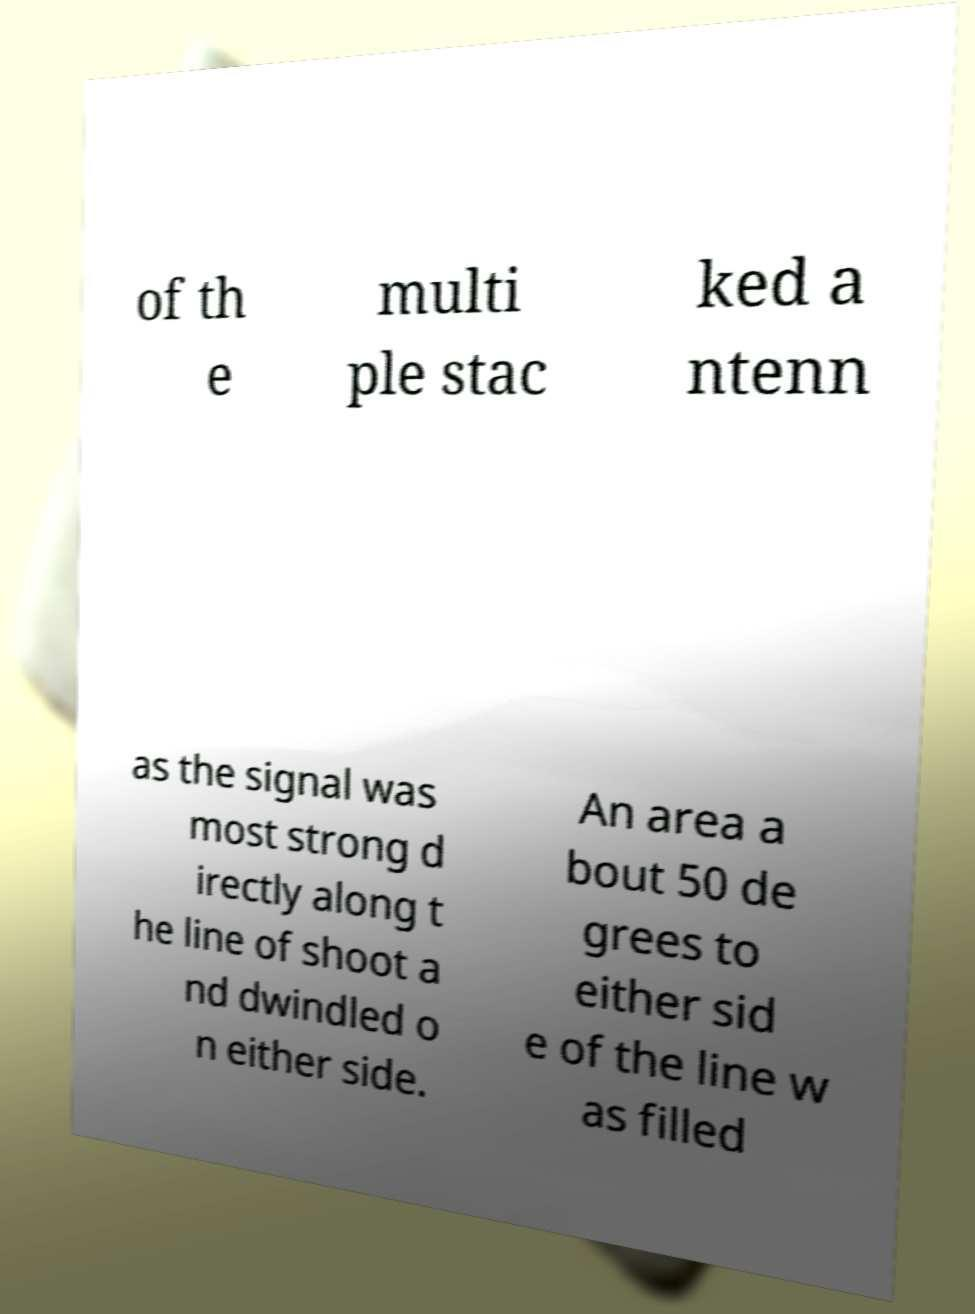Please read and relay the text visible in this image. What does it say? of th e multi ple stac ked a ntenn as the signal was most strong d irectly along t he line of shoot a nd dwindled o n either side. An area a bout 50 de grees to either sid e of the line w as filled 